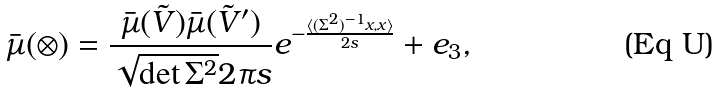Convert formula to latex. <formula><loc_0><loc_0><loc_500><loc_500>\bar { \mu } ( \otimes ) = \frac { \bar { \mu } ( \tilde { V } ) \bar { \mu } ( \tilde { V } ^ { \prime } ) } { \sqrt { \det \Sigma ^ { 2 } } 2 \pi s } e ^ { - \frac { \langle ( \Sigma ^ { 2 } ) ^ { - 1 } x , x \rangle } { 2 s } } + e _ { 3 } ,</formula> 